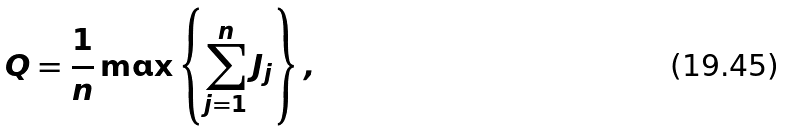<formula> <loc_0><loc_0><loc_500><loc_500>Q = \frac { 1 } { n } \max \left \{ \sum _ { j = 1 } ^ { n } J _ { j } \right \} ,</formula> 